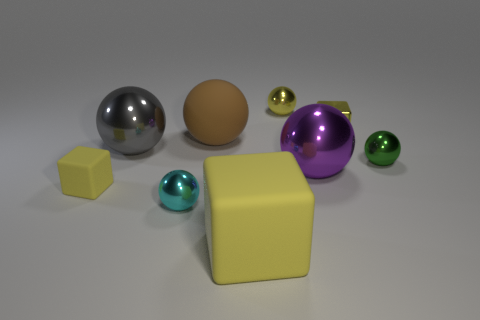There is a cube that is made of the same material as the small cyan thing; what size is it?
Make the answer very short. Small. Do the small cyan metallic thing and the big shiny thing behind the purple metallic thing have the same shape?
Provide a short and direct response. Yes. What size is the yellow metal sphere?
Make the answer very short. Small. Are there fewer shiny blocks left of the big yellow block than big shiny cylinders?
Offer a very short reply. No. What number of green metallic spheres have the same size as the rubber ball?
Ensure brevity in your answer.  0. There is a big rubber thing that is the same color as the metal cube; what shape is it?
Keep it short and to the point. Cube. There is a large ball that is to the left of the cyan metallic thing; is its color the same as the sphere behind the rubber sphere?
Your response must be concise. No. How many cyan metal spheres are on the right side of the large yellow rubber block?
Your answer should be very brief. 0. There is a metal ball that is the same color as the big cube; what is its size?
Your answer should be very brief. Small. Is there another big rubber object of the same shape as the large yellow rubber object?
Give a very brief answer. No. 